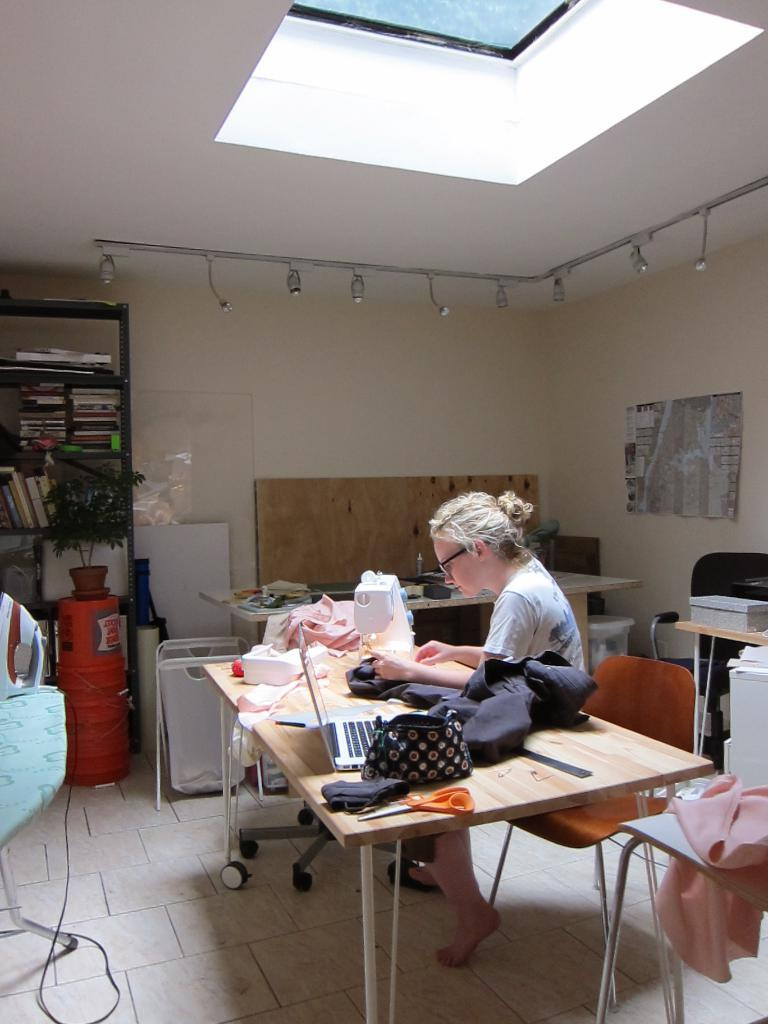What is the woman in the image doing? The woman is sitting on a chair. What is on the table in the image? There is a purse and a sewing machine on the table. What can be seen on the shelf in the background? The shelf contains books and a plant. How does the woman express her feelings about the receipt in the image? There is no receipt present in the image, so it is not possible to determine how the woman might express her feelings about it. 